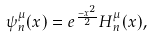<formula> <loc_0><loc_0><loc_500><loc_500>\psi _ { n } ^ { \mu } ( x ) & = e ^ { \frac { - x ^ { 2 } } { 2 } } H _ { n } ^ { \mu } ( x ) ,</formula> 